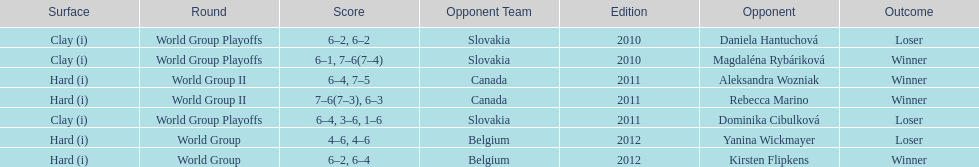What is the other year slovakia played besides 2010? 2011. 